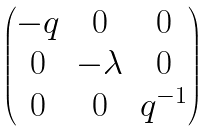<formula> <loc_0><loc_0><loc_500><loc_500>\begin{pmatrix} - q & 0 & 0 \\ 0 & - \lambda & 0 \\ 0 & 0 & q ^ { - 1 } \end{pmatrix}</formula> 